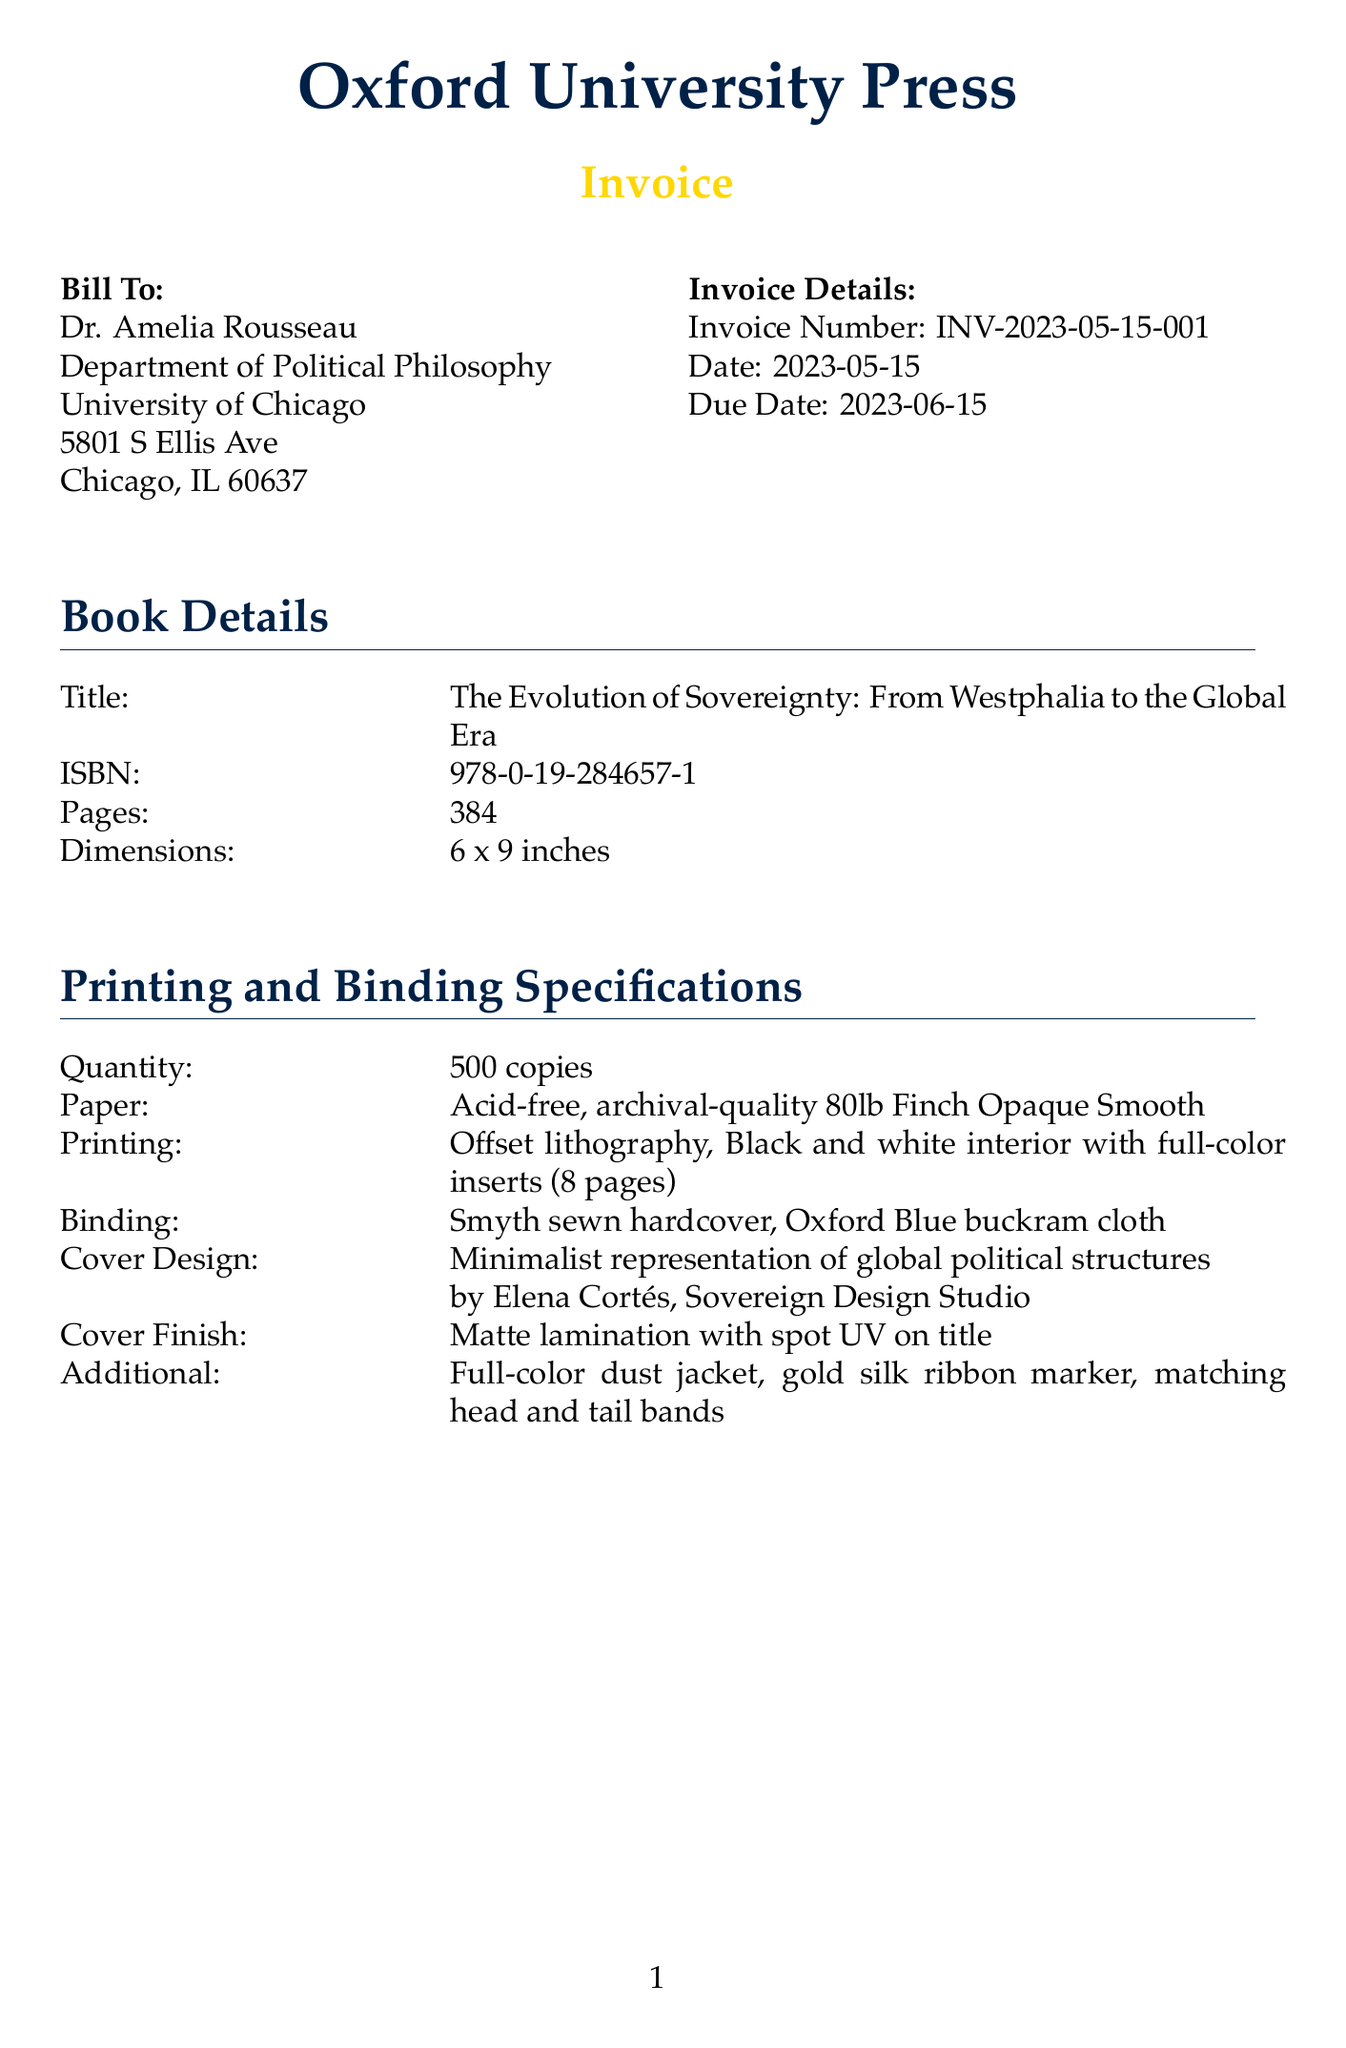What is the invoice number? The invoice number is specified at the beginning of the invoice details section.
Answer: INV-2023-05-15-001 Who is the author of the book? The author's name is listed in the invoice details section.
Answer: Dr. Amelia Rousseau What is the total cost of printing? The total printing cost is provided in the pricing breakdown section.
Answer: 4500 What type of paper is used for printing? The type of paper is specified in the printing specifications section.
Answer: Acid-free, archival-quality 80lb Finch Opaque Smooth What is the cover design style? The cover design style is mentioned in the cover design specifications.
Answer: Minimalist representation of global political structures What is the total grand total amount due? The grand total amount is calculated in the pricing breakdown section.
Answer: 11,166.40 What shipping method is used? The shipping method is indicated in the shipping section of the invoice.
Answer: FedEx Ground What is the quantity of copies printed? The quantity can be found in the printing specifications section.
Answer: 500 copies What are the payment terms? Payment terms are specified at the end of the invoice document.
Answer: Net 30, 2% discount if paid within 10 days 